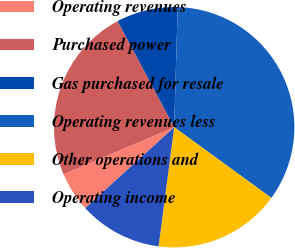<chart> <loc_0><loc_0><loc_500><loc_500><pie_chart><fcel>Operating revenues<fcel>Purchased power<fcel>Gas purchased for resale<fcel>Operating revenues less<fcel>Other operations and<fcel>Operating income<nl><fcel>5.34%<fcel>23.62%<fcel>8.26%<fcel>34.55%<fcel>17.06%<fcel>11.18%<nl></chart> 